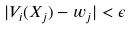Convert formula to latex. <formula><loc_0><loc_0><loc_500><loc_500>| V _ { i } ( X _ { j } ) - w _ { j } | < \epsilon</formula> 